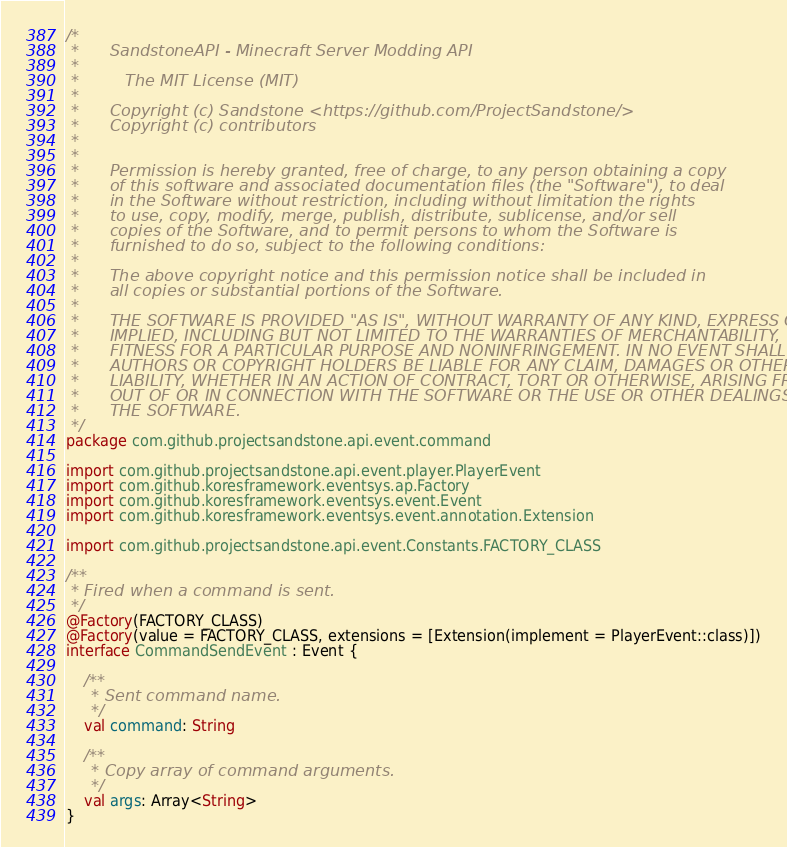<code> <loc_0><loc_0><loc_500><loc_500><_Kotlin_>/*
 *      SandstoneAPI - Minecraft Server Modding API
 *
 *         The MIT License (MIT)
 *
 *      Copyright (c) Sandstone <https://github.com/ProjectSandstone/>
 *      Copyright (c) contributors
 *
 *
 *      Permission is hereby granted, free of charge, to any person obtaining a copy
 *      of this software and associated documentation files (the "Software"), to deal
 *      in the Software without restriction, including without limitation the rights
 *      to use, copy, modify, merge, publish, distribute, sublicense, and/or sell
 *      copies of the Software, and to permit persons to whom the Software is
 *      furnished to do so, subject to the following conditions:
 *
 *      The above copyright notice and this permission notice shall be included in
 *      all copies or substantial portions of the Software.
 *
 *      THE SOFTWARE IS PROVIDED "AS IS", WITHOUT WARRANTY OF ANY KIND, EXPRESS OR
 *      IMPLIED, INCLUDING BUT NOT LIMITED TO THE WARRANTIES OF MERCHANTABILITY,
 *      FITNESS FOR A PARTICULAR PURPOSE AND NONINFRINGEMENT. IN NO EVENT SHALL THE
 *      AUTHORS OR COPYRIGHT HOLDERS BE LIABLE FOR ANY CLAIM, DAMAGES OR OTHER
 *      LIABILITY, WHETHER IN AN ACTION OF CONTRACT, TORT OR OTHERWISE, ARISING FROM,
 *      OUT OF OR IN CONNECTION WITH THE SOFTWARE OR THE USE OR OTHER DEALINGS IN
 *      THE SOFTWARE.
 */
package com.github.projectsandstone.api.event.command

import com.github.projectsandstone.api.event.player.PlayerEvent
import com.github.koresframework.eventsys.ap.Factory
import com.github.koresframework.eventsys.event.Event
import com.github.koresframework.eventsys.event.annotation.Extension

import com.github.projectsandstone.api.event.Constants.FACTORY_CLASS

/**
 * Fired when a command is sent.
 */
@Factory(FACTORY_CLASS)
@Factory(value = FACTORY_CLASS, extensions = [Extension(implement = PlayerEvent::class)])
interface CommandSendEvent : Event {

    /**
     * Sent command name.
     */
    val command: String

    /**
     * Copy array of command arguments.
     */
    val args: Array<String>
}
</code> 